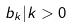<formula> <loc_0><loc_0><loc_500><loc_500>b _ { k } | k > 0</formula> 